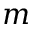<formula> <loc_0><loc_0><loc_500><loc_500>m</formula> 